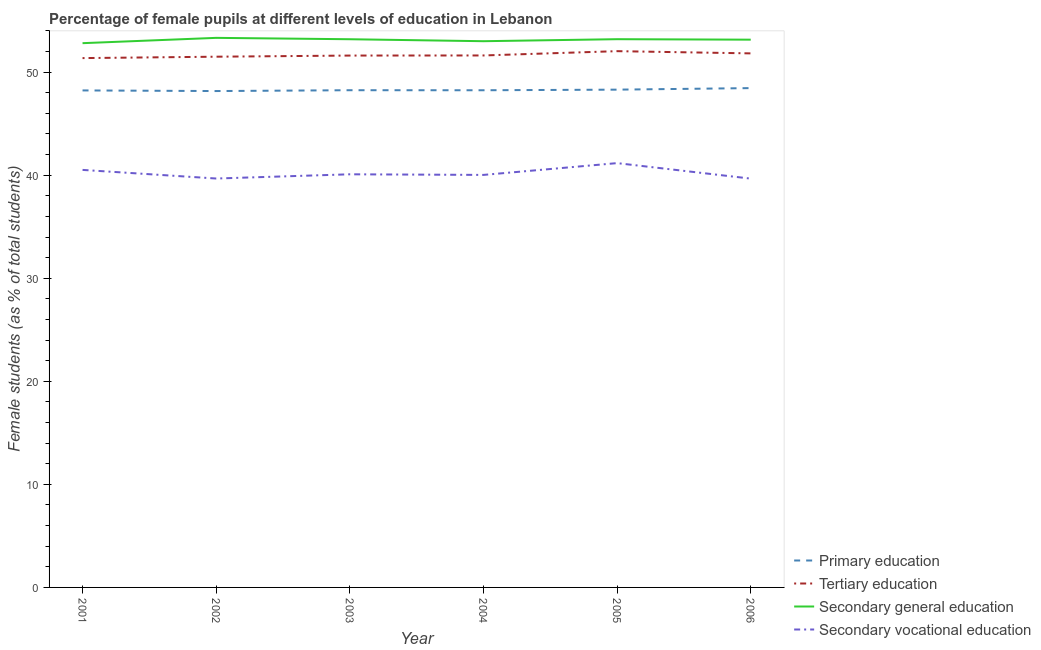How many different coloured lines are there?
Offer a very short reply. 4. Does the line corresponding to percentage of female students in secondary vocational education intersect with the line corresponding to percentage of female students in secondary education?
Provide a succinct answer. No. What is the percentage of female students in secondary vocational education in 2001?
Provide a succinct answer. 40.51. Across all years, what is the maximum percentage of female students in secondary education?
Your answer should be compact. 53.33. Across all years, what is the minimum percentage of female students in primary education?
Offer a very short reply. 48.17. What is the total percentage of female students in secondary education in the graph?
Your response must be concise. 318.68. What is the difference between the percentage of female students in primary education in 2002 and that in 2003?
Offer a very short reply. -0.08. What is the difference between the percentage of female students in tertiary education in 2004 and the percentage of female students in secondary vocational education in 2006?
Keep it short and to the point. 11.95. What is the average percentage of female students in secondary vocational education per year?
Offer a terse response. 40.19. In the year 2002, what is the difference between the percentage of female students in secondary education and percentage of female students in secondary vocational education?
Your answer should be compact. 13.65. What is the ratio of the percentage of female students in tertiary education in 2003 to that in 2005?
Give a very brief answer. 0.99. Is the difference between the percentage of female students in primary education in 2003 and 2006 greater than the difference between the percentage of female students in secondary vocational education in 2003 and 2006?
Your response must be concise. No. What is the difference between the highest and the second highest percentage of female students in secondary education?
Ensure brevity in your answer.  0.13. What is the difference between the highest and the lowest percentage of female students in tertiary education?
Your response must be concise. 0.67. Is the sum of the percentage of female students in tertiary education in 2003 and 2006 greater than the maximum percentage of female students in secondary vocational education across all years?
Keep it short and to the point. Yes. Does the percentage of female students in tertiary education monotonically increase over the years?
Your answer should be very brief. No. Is the percentage of female students in secondary vocational education strictly less than the percentage of female students in tertiary education over the years?
Your answer should be very brief. Yes. How many lines are there?
Ensure brevity in your answer.  4. Does the graph contain grids?
Offer a terse response. No. Where does the legend appear in the graph?
Offer a terse response. Bottom right. What is the title of the graph?
Your response must be concise. Percentage of female pupils at different levels of education in Lebanon. What is the label or title of the X-axis?
Make the answer very short. Year. What is the label or title of the Y-axis?
Keep it short and to the point. Female students (as % of total students). What is the Female students (as % of total students) in Primary education in 2001?
Ensure brevity in your answer.  48.23. What is the Female students (as % of total students) of Tertiary education in 2001?
Offer a very short reply. 51.36. What is the Female students (as % of total students) of Secondary general education in 2001?
Give a very brief answer. 52.81. What is the Female students (as % of total students) in Secondary vocational education in 2001?
Provide a short and direct response. 40.51. What is the Female students (as % of total students) of Primary education in 2002?
Keep it short and to the point. 48.17. What is the Female students (as % of total students) of Tertiary education in 2002?
Provide a succinct answer. 51.5. What is the Female students (as % of total students) in Secondary general education in 2002?
Give a very brief answer. 53.33. What is the Female students (as % of total students) of Secondary vocational education in 2002?
Offer a very short reply. 39.68. What is the Female students (as % of total students) in Primary education in 2003?
Your answer should be very brief. 48.25. What is the Female students (as % of total students) of Tertiary education in 2003?
Provide a short and direct response. 51.61. What is the Female students (as % of total students) in Secondary general education in 2003?
Make the answer very short. 53.19. What is the Female students (as % of total students) in Secondary vocational education in 2003?
Keep it short and to the point. 40.09. What is the Female students (as % of total students) in Primary education in 2004?
Keep it short and to the point. 48.24. What is the Female students (as % of total students) of Tertiary education in 2004?
Your response must be concise. 51.62. What is the Female students (as % of total students) in Secondary general education in 2004?
Your response must be concise. 53. What is the Female students (as % of total students) of Secondary vocational education in 2004?
Offer a terse response. 40.03. What is the Female students (as % of total students) in Primary education in 2005?
Make the answer very short. 48.3. What is the Female students (as % of total students) in Tertiary education in 2005?
Provide a short and direct response. 52.04. What is the Female students (as % of total students) in Secondary general education in 2005?
Your response must be concise. 53.2. What is the Female students (as % of total students) of Secondary vocational education in 2005?
Keep it short and to the point. 41.17. What is the Female students (as % of total students) in Primary education in 2006?
Offer a very short reply. 48.45. What is the Female students (as % of total students) of Tertiary education in 2006?
Give a very brief answer. 51.82. What is the Female students (as % of total students) of Secondary general education in 2006?
Offer a terse response. 53.15. What is the Female students (as % of total students) of Secondary vocational education in 2006?
Make the answer very short. 39.67. Across all years, what is the maximum Female students (as % of total students) of Primary education?
Provide a succinct answer. 48.45. Across all years, what is the maximum Female students (as % of total students) of Tertiary education?
Offer a terse response. 52.04. Across all years, what is the maximum Female students (as % of total students) in Secondary general education?
Provide a succinct answer. 53.33. Across all years, what is the maximum Female students (as % of total students) in Secondary vocational education?
Your answer should be very brief. 41.17. Across all years, what is the minimum Female students (as % of total students) of Primary education?
Your response must be concise. 48.17. Across all years, what is the minimum Female students (as % of total students) in Tertiary education?
Provide a short and direct response. 51.36. Across all years, what is the minimum Female students (as % of total students) in Secondary general education?
Keep it short and to the point. 52.81. Across all years, what is the minimum Female students (as % of total students) in Secondary vocational education?
Your answer should be compact. 39.67. What is the total Female students (as % of total students) in Primary education in the graph?
Your answer should be compact. 289.64. What is the total Female students (as % of total students) of Tertiary education in the graph?
Your answer should be very brief. 309.95. What is the total Female students (as % of total students) of Secondary general education in the graph?
Your answer should be very brief. 318.68. What is the total Female students (as % of total students) of Secondary vocational education in the graph?
Offer a terse response. 241.15. What is the difference between the Female students (as % of total students) of Primary education in 2001 and that in 2002?
Your response must be concise. 0.06. What is the difference between the Female students (as % of total students) of Tertiary education in 2001 and that in 2002?
Ensure brevity in your answer.  -0.14. What is the difference between the Female students (as % of total students) in Secondary general education in 2001 and that in 2002?
Your answer should be very brief. -0.51. What is the difference between the Female students (as % of total students) of Secondary vocational education in 2001 and that in 2002?
Provide a short and direct response. 0.84. What is the difference between the Female students (as % of total students) in Primary education in 2001 and that in 2003?
Make the answer very short. -0.02. What is the difference between the Female students (as % of total students) in Tertiary education in 2001 and that in 2003?
Offer a terse response. -0.25. What is the difference between the Female students (as % of total students) of Secondary general education in 2001 and that in 2003?
Give a very brief answer. -0.38. What is the difference between the Female students (as % of total students) of Secondary vocational education in 2001 and that in 2003?
Provide a succinct answer. 0.43. What is the difference between the Female students (as % of total students) of Primary education in 2001 and that in 2004?
Your response must be concise. -0.02. What is the difference between the Female students (as % of total students) of Tertiary education in 2001 and that in 2004?
Give a very brief answer. -0.26. What is the difference between the Female students (as % of total students) in Secondary general education in 2001 and that in 2004?
Provide a short and direct response. -0.19. What is the difference between the Female students (as % of total students) in Secondary vocational education in 2001 and that in 2004?
Your response must be concise. 0.49. What is the difference between the Female students (as % of total students) in Primary education in 2001 and that in 2005?
Ensure brevity in your answer.  -0.08. What is the difference between the Female students (as % of total students) of Tertiary education in 2001 and that in 2005?
Provide a succinct answer. -0.67. What is the difference between the Female students (as % of total students) in Secondary general education in 2001 and that in 2005?
Ensure brevity in your answer.  -0.39. What is the difference between the Female students (as % of total students) in Secondary vocational education in 2001 and that in 2005?
Ensure brevity in your answer.  -0.66. What is the difference between the Female students (as % of total students) in Primary education in 2001 and that in 2006?
Give a very brief answer. -0.23. What is the difference between the Female students (as % of total students) of Tertiary education in 2001 and that in 2006?
Your response must be concise. -0.46. What is the difference between the Female students (as % of total students) in Secondary general education in 2001 and that in 2006?
Give a very brief answer. -0.34. What is the difference between the Female students (as % of total students) in Secondary vocational education in 2001 and that in 2006?
Keep it short and to the point. 0.85. What is the difference between the Female students (as % of total students) of Primary education in 2002 and that in 2003?
Give a very brief answer. -0.08. What is the difference between the Female students (as % of total students) in Tertiary education in 2002 and that in 2003?
Provide a succinct answer. -0.11. What is the difference between the Female students (as % of total students) in Secondary general education in 2002 and that in 2003?
Your response must be concise. 0.13. What is the difference between the Female students (as % of total students) of Secondary vocational education in 2002 and that in 2003?
Ensure brevity in your answer.  -0.41. What is the difference between the Female students (as % of total students) of Primary education in 2002 and that in 2004?
Provide a short and direct response. -0.08. What is the difference between the Female students (as % of total students) of Tertiary education in 2002 and that in 2004?
Your answer should be compact. -0.12. What is the difference between the Female students (as % of total students) of Secondary general education in 2002 and that in 2004?
Offer a terse response. 0.32. What is the difference between the Female students (as % of total students) of Secondary vocational education in 2002 and that in 2004?
Offer a very short reply. -0.35. What is the difference between the Female students (as % of total students) in Primary education in 2002 and that in 2005?
Your answer should be compact. -0.14. What is the difference between the Female students (as % of total students) in Tertiary education in 2002 and that in 2005?
Provide a succinct answer. -0.54. What is the difference between the Female students (as % of total students) in Secondary general education in 2002 and that in 2005?
Offer a very short reply. 0.13. What is the difference between the Female students (as % of total students) in Secondary vocational education in 2002 and that in 2005?
Keep it short and to the point. -1.49. What is the difference between the Female students (as % of total students) in Primary education in 2002 and that in 2006?
Offer a terse response. -0.29. What is the difference between the Female students (as % of total students) of Tertiary education in 2002 and that in 2006?
Your response must be concise. -0.32. What is the difference between the Female students (as % of total students) of Secondary general education in 2002 and that in 2006?
Give a very brief answer. 0.18. What is the difference between the Female students (as % of total students) in Secondary vocational education in 2002 and that in 2006?
Offer a terse response. 0.01. What is the difference between the Female students (as % of total students) of Primary education in 2003 and that in 2004?
Provide a short and direct response. 0. What is the difference between the Female students (as % of total students) of Tertiary education in 2003 and that in 2004?
Give a very brief answer. -0.01. What is the difference between the Female students (as % of total students) of Secondary general education in 2003 and that in 2004?
Make the answer very short. 0.19. What is the difference between the Female students (as % of total students) of Secondary vocational education in 2003 and that in 2004?
Offer a terse response. 0.06. What is the difference between the Female students (as % of total students) of Primary education in 2003 and that in 2005?
Make the answer very short. -0.05. What is the difference between the Female students (as % of total students) in Tertiary education in 2003 and that in 2005?
Your answer should be compact. -0.43. What is the difference between the Female students (as % of total students) of Secondary general education in 2003 and that in 2005?
Your response must be concise. -0. What is the difference between the Female students (as % of total students) in Secondary vocational education in 2003 and that in 2005?
Offer a terse response. -1.08. What is the difference between the Female students (as % of total students) of Primary education in 2003 and that in 2006?
Provide a succinct answer. -0.2. What is the difference between the Female students (as % of total students) in Tertiary education in 2003 and that in 2006?
Make the answer very short. -0.21. What is the difference between the Female students (as % of total students) of Secondary general education in 2003 and that in 2006?
Provide a short and direct response. 0.04. What is the difference between the Female students (as % of total students) in Secondary vocational education in 2003 and that in 2006?
Keep it short and to the point. 0.42. What is the difference between the Female students (as % of total students) in Primary education in 2004 and that in 2005?
Provide a short and direct response. -0.06. What is the difference between the Female students (as % of total students) in Tertiary education in 2004 and that in 2005?
Provide a succinct answer. -0.42. What is the difference between the Female students (as % of total students) in Secondary general education in 2004 and that in 2005?
Offer a very short reply. -0.2. What is the difference between the Female students (as % of total students) in Secondary vocational education in 2004 and that in 2005?
Keep it short and to the point. -1.14. What is the difference between the Female students (as % of total students) in Primary education in 2004 and that in 2006?
Give a very brief answer. -0.21. What is the difference between the Female students (as % of total students) of Tertiary education in 2004 and that in 2006?
Keep it short and to the point. -0.2. What is the difference between the Female students (as % of total students) of Secondary general education in 2004 and that in 2006?
Offer a very short reply. -0.15. What is the difference between the Female students (as % of total students) of Secondary vocational education in 2004 and that in 2006?
Keep it short and to the point. 0.36. What is the difference between the Female students (as % of total students) in Primary education in 2005 and that in 2006?
Give a very brief answer. -0.15. What is the difference between the Female students (as % of total students) of Tertiary education in 2005 and that in 2006?
Ensure brevity in your answer.  0.22. What is the difference between the Female students (as % of total students) in Secondary general education in 2005 and that in 2006?
Your response must be concise. 0.05. What is the difference between the Female students (as % of total students) in Secondary vocational education in 2005 and that in 2006?
Offer a very short reply. 1.5. What is the difference between the Female students (as % of total students) in Primary education in 2001 and the Female students (as % of total students) in Tertiary education in 2002?
Your answer should be compact. -3.27. What is the difference between the Female students (as % of total students) of Primary education in 2001 and the Female students (as % of total students) of Secondary general education in 2002?
Give a very brief answer. -5.1. What is the difference between the Female students (as % of total students) in Primary education in 2001 and the Female students (as % of total students) in Secondary vocational education in 2002?
Provide a short and direct response. 8.55. What is the difference between the Female students (as % of total students) of Tertiary education in 2001 and the Female students (as % of total students) of Secondary general education in 2002?
Provide a succinct answer. -1.96. What is the difference between the Female students (as % of total students) of Tertiary education in 2001 and the Female students (as % of total students) of Secondary vocational education in 2002?
Make the answer very short. 11.68. What is the difference between the Female students (as % of total students) of Secondary general education in 2001 and the Female students (as % of total students) of Secondary vocational education in 2002?
Ensure brevity in your answer.  13.13. What is the difference between the Female students (as % of total students) in Primary education in 2001 and the Female students (as % of total students) in Tertiary education in 2003?
Make the answer very short. -3.38. What is the difference between the Female students (as % of total students) in Primary education in 2001 and the Female students (as % of total students) in Secondary general education in 2003?
Provide a short and direct response. -4.97. What is the difference between the Female students (as % of total students) in Primary education in 2001 and the Female students (as % of total students) in Secondary vocational education in 2003?
Offer a terse response. 8.14. What is the difference between the Female students (as % of total students) of Tertiary education in 2001 and the Female students (as % of total students) of Secondary general education in 2003?
Keep it short and to the point. -1.83. What is the difference between the Female students (as % of total students) in Tertiary education in 2001 and the Female students (as % of total students) in Secondary vocational education in 2003?
Offer a terse response. 11.28. What is the difference between the Female students (as % of total students) in Secondary general education in 2001 and the Female students (as % of total students) in Secondary vocational education in 2003?
Your response must be concise. 12.72. What is the difference between the Female students (as % of total students) of Primary education in 2001 and the Female students (as % of total students) of Tertiary education in 2004?
Provide a succinct answer. -3.39. What is the difference between the Female students (as % of total students) in Primary education in 2001 and the Female students (as % of total students) in Secondary general education in 2004?
Keep it short and to the point. -4.78. What is the difference between the Female students (as % of total students) of Primary education in 2001 and the Female students (as % of total students) of Secondary vocational education in 2004?
Give a very brief answer. 8.2. What is the difference between the Female students (as % of total students) in Tertiary education in 2001 and the Female students (as % of total students) in Secondary general education in 2004?
Your answer should be very brief. -1.64. What is the difference between the Female students (as % of total students) of Tertiary education in 2001 and the Female students (as % of total students) of Secondary vocational education in 2004?
Your answer should be compact. 11.33. What is the difference between the Female students (as % of total students) in Secondary general education in 2001 and the Female students (as % of total students) in Secondary vocational education in 2004?
Your response must be concise. 12.78. What is the difference between the Female students (as % of total students) of Primary education in 2001 and the Female students (as % of total students) of Tertiary education in 2005?
Make the answer very short. -3.81. What is the difference between the Female students (as % of total students) in Primary education in 2001 and the Female students (as % of total students) in Secondary general education in 2005?
Offer a very short reply. -4.97. What is the difference between the Female students (as % of total students) of Primary education in 2001 and the Female students (as % of total students) of Secondary vocational education in 2005?
Provide a short and direct response. 7.05. What is the difference between the Female students (as % of total students) in Tertiary education in 2001 and the Female students (as % of total students) in Secondary general education in 2005?
Your answer should be very brief. -1.83. What is the difference between the Female students (as % of total students) in Tertiary education in 2001 and the Female students (as % of total students) in Secondary vocational education in 2005?
Your answer should be compact. 10.19. What is the difference between the Female students (as % of total students) in Secondary general education in 2001 and the Female students (as % of total students) in Secondary vocational education in 2005?
Offer a very short reply. 11.64. What is the difference between the Female students (as % of total students) of Primary education in 2001 and the Female students (as % of total students) of Tertiary education in 2006?
Keep it short and to the point. -3.59. What is the difference between the Female students (as % of total students) in Primary education in 2001 and the Female students (as % of total students) in Secondary general education in 2006?
Offer a very short reply. -4.93. What is the difference between the Female students (as % of total students) of Primary education in 2001 and the Female students (as % of total students) of Secondary vocational education in 2006?
Make the answer very short. 8.56. What is the difference between the Female students (as % of total students) in Tertiary education in 2001 and the Female students (as % of total students) in Secondary general education in 2006?
Your answer should be compact. -1.79. What is the difference between the Female students (as % of total students) in Tertiary education in 2001 and the Female students (as % of total students) in Secondary vocational education in 2006?
Offer a very short reply. 11.69. What is the difference between the Female students (as % of total students) of Secondary general education in 2001 and the Female students (as % of total students) of Secondary vocational education in 2006?
Your response must be concise. 13.14. What is the difference between the Female students (as % of total students) of Primary education in 2002 and the Female students (as % of total students) of Tertiary education in 2003?
Your response must be concise. -3.44. What is the difference between the Female students (as % of total students) of Primary education in 2002 and the Female students (as % of total students) of Secondary general education in 2003?
Provide a succinct answer. -5.03. What is the difference between the Female students (as % of total students) in Primary education in 2002 and the Female students (as % of total students) in Secondary vocational education in 2003?
Offer a terse response. 8.08. What is the difference between the Female students (as % of total students) in Tertiary education in 2002 and the Female students (as % of total students) in Secondary general education in 2003?
Make the answer very short. -1.69. What is the difference between the Female students (as % of total students) of Tertiary education in 2002 and the Female students (as % of total students) of Secondary vocational education in 2003?
Make the answer very short. 11.41. What is the difference between the Female students (as % of total students) in Secondary general education in 2002 and the Female students (as % of total students) in Secondary vocational education in 2003?
Offer a terse response. 13.24. What is the difference between the Female students (as % of total students) of Primary education in 2002 and the Female students (as % of total students) of Tertiary education in 2004?
Provide a short and direct response. -3.45. What is the difference between the Female students (as % of total students) in Primary education in 2002 and the Female students (as % of total students) in Secondary general education in 2004?
Your response must be concise. -4.84. What is the difference between the Female students (as % of total students) in Primary education in 2002 and the Female students (as % of total students) in Secondary vocational education in 2004?
Your answer should be very brief. 8.14. What is the difference between the Female students (as % of total students) in Tertiary education in 2002 and the Female students (as % of total students) in Secondary general education in 2004?
Provide a succinct answer. -1.5. What is the difference between the Female students (as % of total students) in Tertiary education in 2002 and the Female students (as % of total students) in Secondary vocational education in 2004?
Your answer should be very brief. 11.47. What is the difference between the Female students (as % of total students) of Secondary general education in 2002 and the Female students (as % of total students) of Secondary vocational education in 2004?
Your response must be concise. 13.3. What is the difference between the Female students (as % of total students) of Primary education in 2002 and the Female students (as % of total students) of Tertiary education in 2005?
Your answer should be very brief. -3.87. What is the difference between the Female students (as % of total students) in Primary education in 2002 and the Female students (as % of total students) in Secondary general education in 2005?
Offer a very short reply. -5.03. What is the difference between the Female students (as % of total students) in Primary education in 2002 and the Female students (as % of total students) in Secondary vocational education in 2005?
Ensure brevity in your answer.  6.99. What is the difference between the Female students (as % of total students) of Tertiary education in 2002 and the Female students (as % of total students) of Secondary general education in 2005?
Provide a short and direct response. -1.7. What is the difference between the Female students (as % of total students) of Tertiary education in 2002 and the Female students (as % of total students) of Secondary vocational education in 2005?
Offer a terse response. 10.33. What is the difference between the Female students (as % of total students) in Secondary general education in 2002 and the Female students (as % of total students) in Secondary vocational education in 2005?
Provide a short and direct response. 12.15. What is the difference between the Female students (as % of total students) in Primary education in 2002 and the Female students (as % of total students) in Tertiary education in 2006?
Ensure brevity in your answer.  -3.65. What is the difference between the Female students (as % of total students) in Primary education in 2002 and the Female students (as % of total students) in Secondary general education in 2006?
Provide a short and direct response. -4.99. What is the difference between the Female students (as % of total students) of Primary education in 2002 and the Female students (as % of total students) of Secondary vocational education in 2006?
Provide a succinct answer. 8.5. What is the difference between the Female students (as % of total students) of Tertiary education in 2002 and the Female students (as % of total students) of Secondary general education in 2006?
Offer a very short reply. -1.65. What is the difference between the Female students (as % of total students) of Tertiary education in 2002 and the Female students (as % of total students) of Secondary vocational education in 2006?
Your answer should be very brief. 11.83. What is the difference between the Female students (as % of total students) of Secondary general education in 2002 and the Female students (as % of total students) of Secondary vocational education in 2006?
Offer a very short reply. 13.66. What is the difference between the Female students (as % of total students) in Primary education in 2003 and the Female students (as % of total students) in Tertiary education in 2004?
Offer a very short reply. -3.37. What is the difference between the Female students (as % of total students) of Primary education in 2003 and the Female students (as % of total students) of Secondary general education in 2004?
Offer a very short reply. -4.76. What is the difference between the Female students (as % of total students) in Primary education in 2003 and the Female students (as % of total students) in Secondary vocational education in 2004?
Your answer should be compact. 8.22. What is the difference between the Female students (as % of total students) in Tertiary education in 2003 and the Female students (as % of total students) in Secondary general education in 2004?
Your response must be concise. -1.39. What is the difference between the Female students (as % of total students) of Tertiary education in 2003 and the Female students (as % of total students) of Secondary vocational education in 2004?
Ensure brevity in your answer.  11.58. What is the difference between the Female students (as % of total students) of Secondary general education in 2003 and the Female students (as % of total students) of Secondary vocational education in 2004?
Offer a very short reply. 13.16. What is the difference between the Female students (as % of total students) in Primary education in 2003 and the Female students (as % of total students) in Tertiary education in 2005?
Keep it short and to the point. -3.79. What is the difference between the Female students (as % of total students) of Primary education in 2003 and the Female students (as % of total students) of Secondary general education in 2005?
Ensure brevity in your answer.  -4.95. What is the difference between the Female students (as % of total students) of Primary education in 2003 and the Female students (as % of total students) of Secondary vocational education in 2005?
Offer a terse response. 7.07. What is the difference between the Female students (as % of total students) in Tertiary education in 2003 and the Female students (as % of total students) in Secondary general education in 2005?
Your answer should be compact. -1.59. What is the difference between the Female students (as % of total students) of Tertiary education in 2003 and the Female students (as % of total students) of Secondary vocational education in 2005?
Your answer should be compact. 10.44. What is the difference between the Female students (as % of total students) of Secondary general education in 2003 and the Female students (as % of total students) of Secondary vocational education in 2005?
Provide a short and direct response. 12.02. What is the difference between the Female students (as % of total students) of Primary education in 2003 and the Female students (as % of total students) of Tertiary education in 2006?
Offer a terse response. -3.57. What is the difference between the Female students (as % of total students) in Primary education in 2003 and the Female students (as % of total students) in Secondary general education in 2006?
Your answer should be very brief. -4.9. What is the difference between the Female students (as % of total students) in Primary education in 2003 and the Female students (as % of total students) in Secondary vocational education in 2006?
Give a very brief answer. 8.58. What is the difference between the Female students (as % of total students) in Tertiary education in 2003 and the Female students (as % of total students) in Secondary general education in 2006?
Provide a short and direct response. -1.54. What is the difference between the Female students (as % of total students) of Tertiary education in 2003 and the Female students (as % of total students) of Secondary vocational education in 2006?
Ensure brevity in your answer.  11.94. What is the difference between the Female students (as % of total students) of Secondary general education in 2003 and the Female students (as % of total students) of Secondary vocational education in 2006?
Ensure brevity in your answer.  13.52. What is the difference between the Female students (as % of total students) in Primary education in 2004 and the Female students (as % of total students) in Tertiary education in 2005?
Offer a terse response. -3.79. What is the difference between the Female students (as % of total students) in Primary education in 2004 and the Female students (as % of total students) in Secondary general education in 2005?
Give a very brief answer. -4.95. What is the difference between the Female students (as % of total students) of Primary education in 2004 and the Female students (as % of total students) of Secondary vocational education in 2005?
Offer a terse response. 7.07. What is the difference between the Female students (as % of total students) in Tertiary education in 2004 and the Female students (as % of total students) in Secondary general education in 2005?
Ensure brevity in your answer.  -1.58. What is the difference between the Female students (as % of total students) in Tertiary education in 2004 and the Female students (as % of total students) in Secondary vocational education in 2005?
Your answer should be compact. 10.45. What is the difference between the Female students (as % of total students) in Secondary general education in 2004 and the Female students (as % of total students) in Secondary vocational education in 2005?
Provide a short and direct response. 11.83. What is the difference between the Female students (as % of total students) of Primary education in 2004 and the Female students (as % of total students) of Tertiary education in 2006?
Your response must be concise. -3.58. What is the difference between the Female students (as % of total students) of Primary education in 2004 and the Female students (as % of total students) of Secondary general education in 2006?
Provide a succinct answer. -4.91. What is the difference between the Female students (as % of total students) in Primary education in 2004 and the Female students (as % of total students) in Secondary vocational education in 2006?
Provide a succinct answer. 8.57. What is the difference between the Female students (as % of total students) of Tertiary education in 2004 and the Female students (as % of total students) of Secondary general education in 2006?
Your answer should be very brief. -1.53. What is the difference between the Female students (as % of total students) in Tertiary education in 2004 and the Female students (as % of total students) in Secondary vocational education in 2006?
Your response must be concise. 11.95. What is the difference between the Female students (as % of total students) of Secondary general education in 2004 and the Female students (as % of total students) of Secondary vocational education in 2006?
Your answer should be compact. 13.33. What is the difference between the Female students (as % of total students) in Primary education in 2005 and the Female students (as % of total students) in Tertiary education in 2006?
Offer a terse response. -3.52. What is the difference between the Female students (as % of total students) in Primary education in 2005 and the Female students (as % of total students) in Secondary general education in 2006?
Ensure brevity in your answer.  -4.85. What is the difference between the Female students (as % of total students) of Primary education in 2005 and the Female students (as % of total students) of Secondary vocational education in 2006?
Offer a very short reply. 8.63. What is the difference between the Female students (as % of total students) in Tertiary education in 2005 and the Female students (as % of total students) in Secondary general education in 2006?
Offer a terse response. -1.11. What is the difference between the Female students (as % of total students) of Tertiary education in 2005 and the Female students (as % of total students) of Secondary vocational education in 2006?
Give a very brief answer. 12.37. What is the difference between the Female students (as % of total students) of Secondary general education in 2005 and the Female students (as % of total students) of Secondary vocational education in 2006?
Your answer should be very brief. 13.53. What is the average Female students (as % of total students) in Primary education per year?
Make the answer very short. 48.27. What is the average Female students (as % of total students) of Tertiary education per year?
Provide a short and direct response. 51.66. What is the average Female students (as % of total students) in Secondary general education per year?
Provide a succinct answer. 53.11. What is the average Female students (as % of total students) of Secondary vocational education per year?
Give a very brief answer. 40.19. In the year 2001, what is the difference between the Female students (as % of total students) in Primary education and Female students (as % of total students) in Tertiary education?
Offer a very short reply. -3.14. In the year 2001, what is the difference between the Female students (as % of total students) in Primary education and Female students (as % of total students) in Secondary general education?
Your answer should be very brief. -4.59. In the year 2001, what is the difference between the Female students (as % of total students) of Primary education and Female students (as % of total students) of Secondary vocational education?
Offer a terse response. 7.71. In the year 2001, what is the difference between the Female students (as % of total students) in Tertiary education and Female students (as % of total students) in Secondary general education?
Provide a short and direct response. -1.45. In the year 2001, what is the difference between the Female students (as % of total students) of Tertiary education and Female students (as % of total students) of Secondary vocational education?
Your answer should be compact. 10.85. In the year 2001, what is the difference between the Female students (as % of total students) in Secondary general education and Female students (as % of total students) in Secondary vocational education?
Make the answer very short. 12.3. In the year 2002, what is the difference between the Female students (as % of total students) in Primary education and Female students (as % of total students) in Tertiary education?
Ensure brevity in your answer.  -3.33. In the year 2002, what is the difference between the Female students (as % of total students) of Primary education and Female students (as % of total students) of Secondary general education?
Ensure brevity in your answer.  -5.16. In the year 2002, what is the difference between the Female students (as % of total students) in Primary education and Female students (as % of total students) in Secondary vocational education?
Ensure brevity in your answer.  8.49. In the year 2002, what is the difference between the Female students (as % of total students) in Tertiary education and Female students (as % of total students) in Secondary general education?
Offer a terse response. -1.83. In the year 2002, what is the difference between the Female students (as % of total students) of Tertiary education and Female students (as % of total students) of Secondary vocational education?
Provide a short and direct response. 11.82. In the year 2002, what is the difference between the Female students (as % of total students) in Secondary general education and Female students (as % of total students) in Secondary vocational education?
Offer a very short reply. 13.65. In the year 2003, what is the difference between the Female students (as % of total students) of Primary education and Female students (as % of total students) of Tertiary education?
Offer a terse response. -3.36. In the year 2003, what is the difference between the Female students (as % of total students) of Primary education and Female students (as % of total students) of Secondary general education?
Your answer should be compact. -4.95. In the year 2003, what is the difference between the Female students (as % of total students) in Primary education and Female students (as % of total students) in Secondary vocational education?
Provide a short and direct response. 8.16. In the year 2003, what is the difference between the Female students (as % of total students) in Tertiary education and Female students (as % of total students) in Secondary general education?
Ensure brevity in your answer.  -1.58. In the year 2003, what is the difference between the Female students (as % of total students) in Tertiary education and Female students (as % of total students) in Secondary vocational education?
Keep it short and to the point. 11.52. In the year 2003, what is the difference between the Female students (as % of total students) of Secondary general education and Female students (as % of total students) of Secondary vocational education?
Provide a short and direct response. 13.11. In the year 2004, what is the difference between the Female students (as % of total students) of Primary education and Female students (as % of total students) of Tertiary education?
Provide a short and direct response. -3.38. In the year 2004, what is the difference between the Female students (as % of total students) in Primary education and Female students (as % of total students) in Secondary general education?
Keep it short and to the point. -4.76. In the year 2004, what is the difference between the Female students (as % of total students) in Primary education and Female students (as % of total students) in Secondary vocational education?
Ensure brevity in your answer.  8.21. In the year 2004, what is the difference between the Female students (as % of total students) in Tertiary education and Female students (as % of total students) in Secondary general education?
Give a very brief answer. -1.38. In the year 2004, what is the difference between the Female students (as % of total students) in Tertiary education and Female students (as % of total students) in Secondary vocational education?
Your response must be concise. 11.59. In the year 2004, what is the difference between the Female students (as % of total students) in Secondary general education and Female students (as % of total students) in Secondary vocational education?
Make the answer very short. 12.97. In the year 2005, what is the difference between the Female students (as % of total students) in Primary education and Female students (as % of total students) in Tertiary education?
Offer a terse response. -3.73. In the year 2005, what is the difference between the Female students (as % of total students) in Primary education and Female students (as % of total students) in Secondary general education?
Offer a terse response. -4.9. In the year 2005, what is the difference between the Female students (as % of total students) in Primary education and Female students (as % of total students) in Secondary vocational education?
Keep it short and to the point. 7.13. In the year 2005, what is the difference between the Female students (as % of total students) in Tertiary education and Female students (as % of total students) in Secondary general education?
Give a very brief answer. -1.16. In the year 2005, what is the difference between the Female students (as % of total students) in Tertiary education and Female students (as % of total students) in Secondary vocational education?
Keep it short and to the point. 10.86. In the year 2005, what is the difference between the Female students (as % of total students) of Secondary general education and Female students (as % of total students) of Secondary vocational education?
Your response must be concise. 12.03. In the year 2006, what is the difference between the Female students (as % of total students) in Primary education and Female students (as % of total students) in Tertiary education?
Offer a very short reply. -3.37. In the year 2006, what is the difference between the Female students (as % of total students) in Primary education and Female students (as % of total students) in Secondary general education?
Provide a succinct answer. -4.7. In the year 2006, what is the difference between the Female students (as % of total students) in Primary education and Female students (as % of total students) in Secondary vocational education?
Your answer should be very brief. 8.78. In the year 2006, what is the difference between the Female students (as % of total students) of Tertiary education and Female students (as % of total students) of Secondary general education?
Your answer should be compact. -1.33. In the year 2006, what is the difference between the Female students (as % of total students) of Tertiary education and Female students (as % of total students) of Secondary vocational education?
Give a very brief answer. 12.15. In the year 2006, what is the difference between the Female students (as % of total students) of Secondary general education and Female students (as % of total students) of Secondary vocational education?
Offer a terse response. 13.48. What is the ratio of the Female students (as % of total students) in Secondary general education in 2001 to that in 2002?
Provide a short and direct response. 0.99. What is the ratio of the Female students (as % of total students) of Secondary vocational education in 2001 to that in 2002?
Ensure brevity in your answer.  1.02. What is the ratio of the Female students (as % of total students) in Primary education in 2001 to that in 2003?
Keep it short and to the point. 1. What is the ratio of the Female students (as % of total students) of Secondary general education in 2001 to that in 2003?
Offer a terse response. 0.99. What is the ratio of the Female students (as % of total students) of Secondary vocational education in 2001 to that in 2003?
Offer a terse response. 1.01. What is the ratio of the Female students (as % of total students) of Primary education in 2001 to that in 2004?
Keep it short and to the point. 1. What is the ratio of the Female students (as % of total students) in Secondary vocational education in 2001 to that in 2004?
Your answer should be very brief. 1.01. What is the ratio of the Female students (as % of total students) of Primary education in 2001 to that in 2005?
Keep it short and to the point. 1. What is the ratio of the Female students (as % of total students) in Tertiary education in 2001 to that in 2005?
Offer a very short reply. 0.99. What is the ratio of the Female students (as % of total students) of Secondary general education in 2001 to that in 2005?
Give a very brief answer. 0.99. What is the ratio of the Female students (as % of total students) of Primary education in 2001 to that in 2006?
Your response must be concise. 1. What is the ratio of the Female students (as % of total students) of Tertiary education in 2001 to that in 2006?
Make the answer very short. 0.99. What is the ratio of the Female students (as % of total students) of Secondary vocational education in 2001 to that in 2006?
Ensure brevity in your answer.  1.02. What is the ratio of the Female students (as % of total students) in Tertiary education in 2002 to that in 2003?
Ensure brevity in your answer.  1. What is the ratio of the Female students (as % of total students) of Secondary general education in 2002 to that in 2003?
Provide a short and direct response. 1. What is the ratio of the Female students (as % of total students) in Primary education in 2002 to that in 2004?
Your answer should be compact. 1. What is the ratio of the Female students (as % of total students) in Tertiary education in 2002 to that in 2004?
Your answer should be very brief. 1. What is the ratio of the Female students (as % of total students) of Secondary general education in 2002 to that in 2004?
Offer a terse response. 1.01. What is the ratio of the Female students (as % of total students) in Primary education in 2002 to that in 2005?
Offer a terse response. 1. What is the ratio of the Female students (as % of total students) in Secondary general education in 2002 to that in 2005?
Give a very brief answer. 1. What is the ratio of the Female students (as % of total students) of Secondary vocational education in 2002 to that in 2005?
Make the answer very short. 0.96. What is the ratio of the Female students (as % of total students) in Secondary general education in 2002 to that in 2006?
Your answer should be very brief. 1. What is the ratio of the Female students (as % of total students) in Secondary vocational education in 2002 to that in 2006?
Provide a succinct answer. 1. What is the ratio of the Female students (as % of total students) of Tertiary education in 2003 to that in 2004?
Keep it short and to the point. 1. What is the ratio of the Female students (as % of total students) in Tertiary education in 2003 to that in 2005?
Keep it short and to the point. 0.99. What is the ratio of the Female students (as % of total students) in Secondary general education in 2003 to that in 2005?
Provide a short and direct response. 1. What is the ratio of the Female students (as % of total students) in Secondary vocational education in 2003 to that in 2005?
Make the answer very short. 0.97. What is the ratio of the Female students (as % of total students) of Primary education in 2003 to that in 2006?
Give a very brief answer. 1. What is the ratio of the Female students (as % of total students) of Tertiary education in 2003 to that in 2006?
Provide a short and direct response. 1. What is the ratio of the Female students (as % of total students) in Secondary vocational education in 2003 to that in 2006?
Make the answer very short. 1.01. What is the ratio of the Female students (as % of total students) of Secondary vocational education in 2004 to that in 2005?
Offer a terse response. 0.97. What is the ratio of the Female students (as % of total students) in Tertiary education in 2004 to that in 2006?
Ensure brevity in your answer.  1. What is the ratio of the Female students (as % of total students) of Secondary vocational education in 2004 to that in 2006?
Your answer should be very brief. 1.01. What is the ratio of the Female students (as % of total students) in Primary education in 2005 to that in 2006?
Offer a very short reply. 1. What is the ratio of the Female students (as % of total students) of Tertiary education in 2005 to that in 2006?
Ensure brevity in your answer.  1. What is the ratio of the Female students (as % of total students) in Secondary general education in 2005 to that in 2006?
Make the answer very short. 1. What is the ratio of the Female students (as % of total students) of Secondary vocational education in 2005 to that in 2006?
Keep it short and to the point. 1.04. What is the difference between the highest and the second highest Female students (as % of total students) in Primary education?
Offer a very short reply. 0.15. What is the difference between the highest and the second highest Female students (as % of total students) in Tertiary education?
Your response must be concise. 0.22. What is the difference between the highest and the second highest Female students (as % of total students) of Secondary general education?
Make the answer very short. 0.13. What is the difference between the highest and the second highest Female students (as % of total students) of Secondary vocational education?
Provide a succinct answer. 0.66. What is the difference between the highest and the lowest Female students (as % of total students) in Primary education?
Provide a succinct answer. 0.29. What is the difference between the highest and the lowest Female students (as % of total students) in Tertiary education?
Keep it short and to the point. 0.67. What is the difference between the highest and the lowest Female students (as % of total students) in Secondary general education?
Ensure brevity in your answer.  0.51. What is the difference between the highest and the lowest Female students (as % of total students) of Secondary vocational education?
Keep it short and to the point. 1.5. 